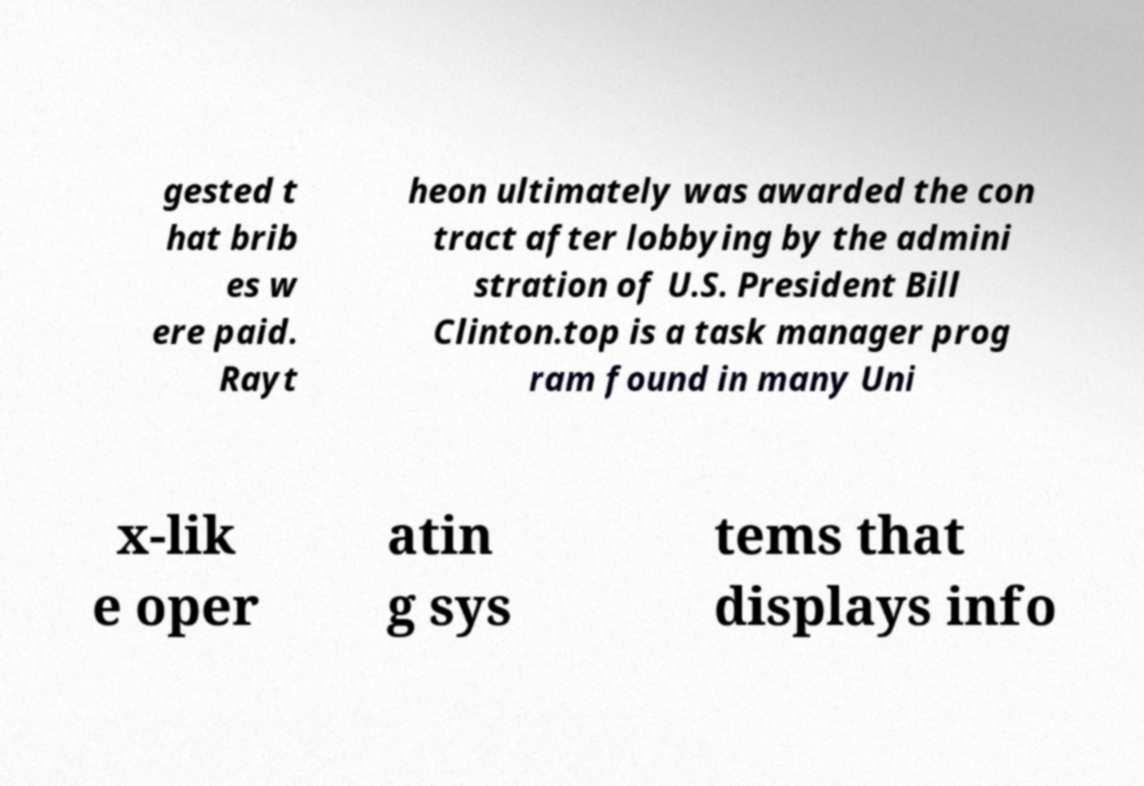Please identify and transcribe the text found in this image. gested t hat brib es w ere paid. Rayt heon ultimately was awarded the con tract after lobbying by the admini stration of U.S. President Bill Clinton.top is a task manager prog ram found in many Uni x-lik e oper atin g sys tems that displays info 